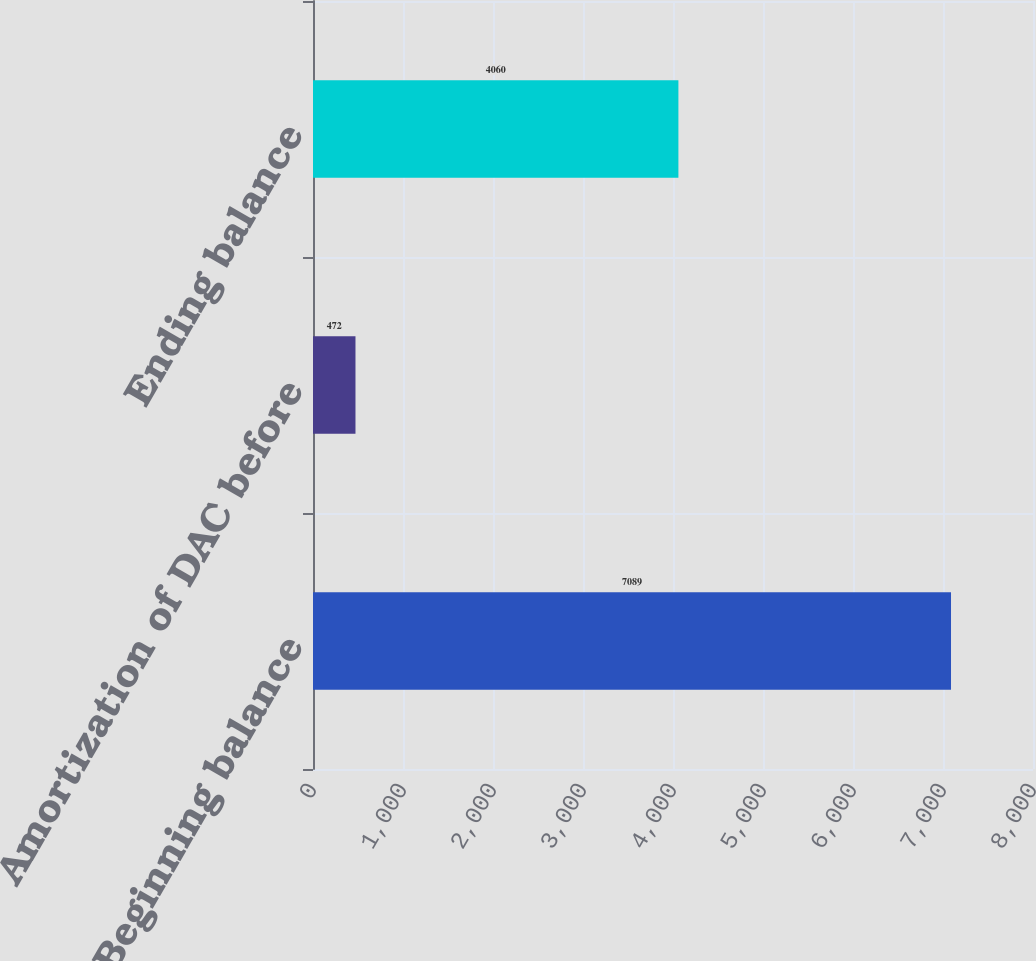Convert chart. <chart><loc_0><loc_0><loc_500><loc_500><bar_chart><fcel>Beginning balance<fcel>Amortization of DAC before<fcel>Ending balance<nl><fcel>7089<fcel>472<fcel>4060<nl></chart> 